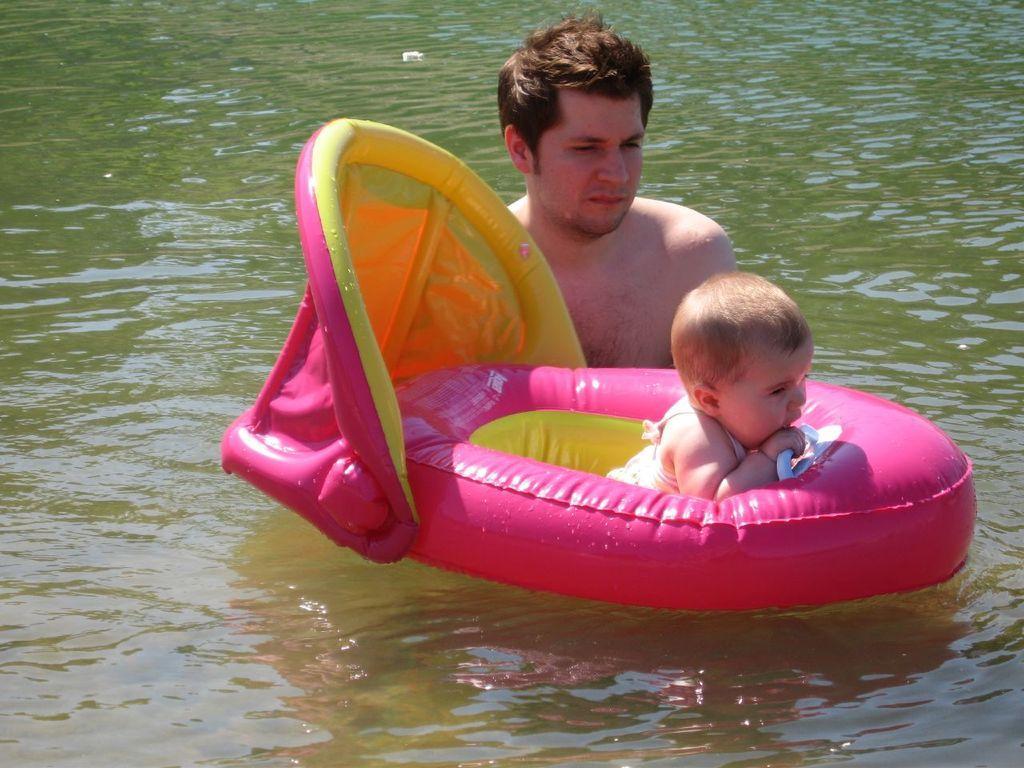Can you describe this image briefly? In this picture I can see there is an infant sitting in a baby floats and there is a man behind the infant and he is looking at the infant. 